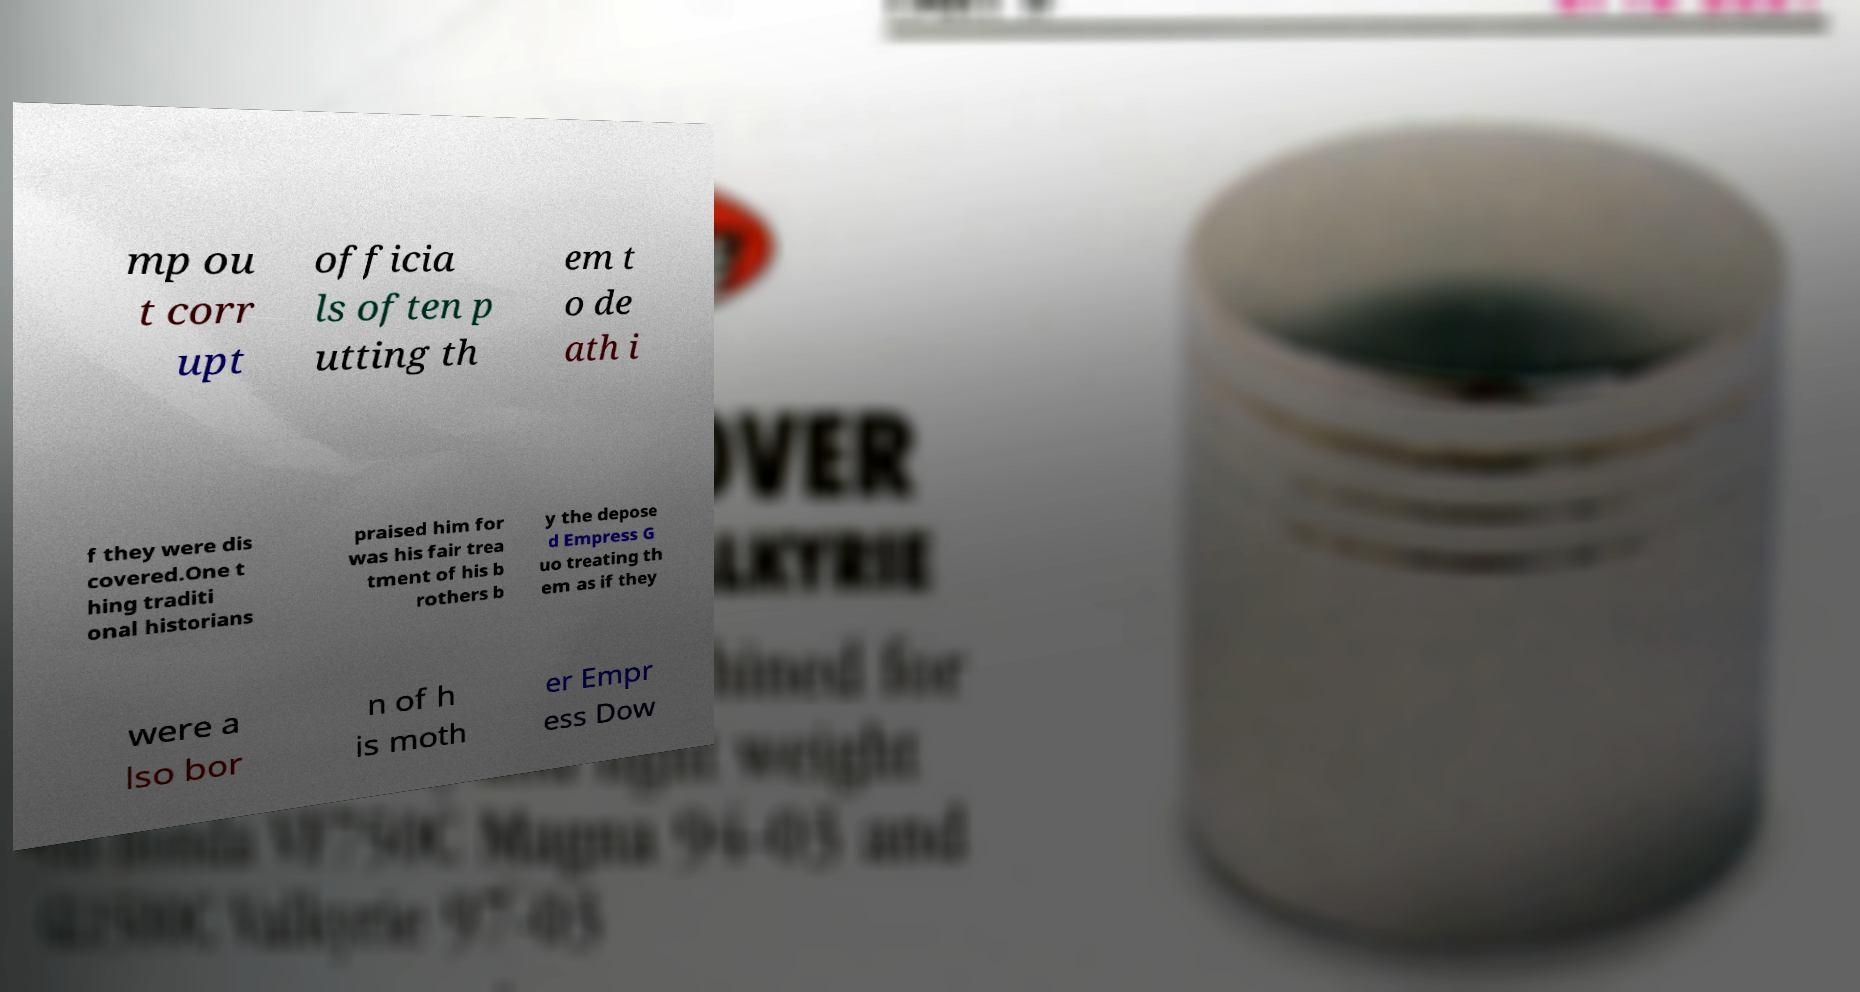For documentation purposes, I need the text within this image transcribed. Could you provide that? mp ou t corr upt officia ls often p utting th em t o de ath i f they were dis covered.One t hing traditi onal historians praised him for was his fair trea tment of his b rothers b y the depose d Empress G uo treating th em as if they were a lso bor n of h is moth er Empr ess Dow 